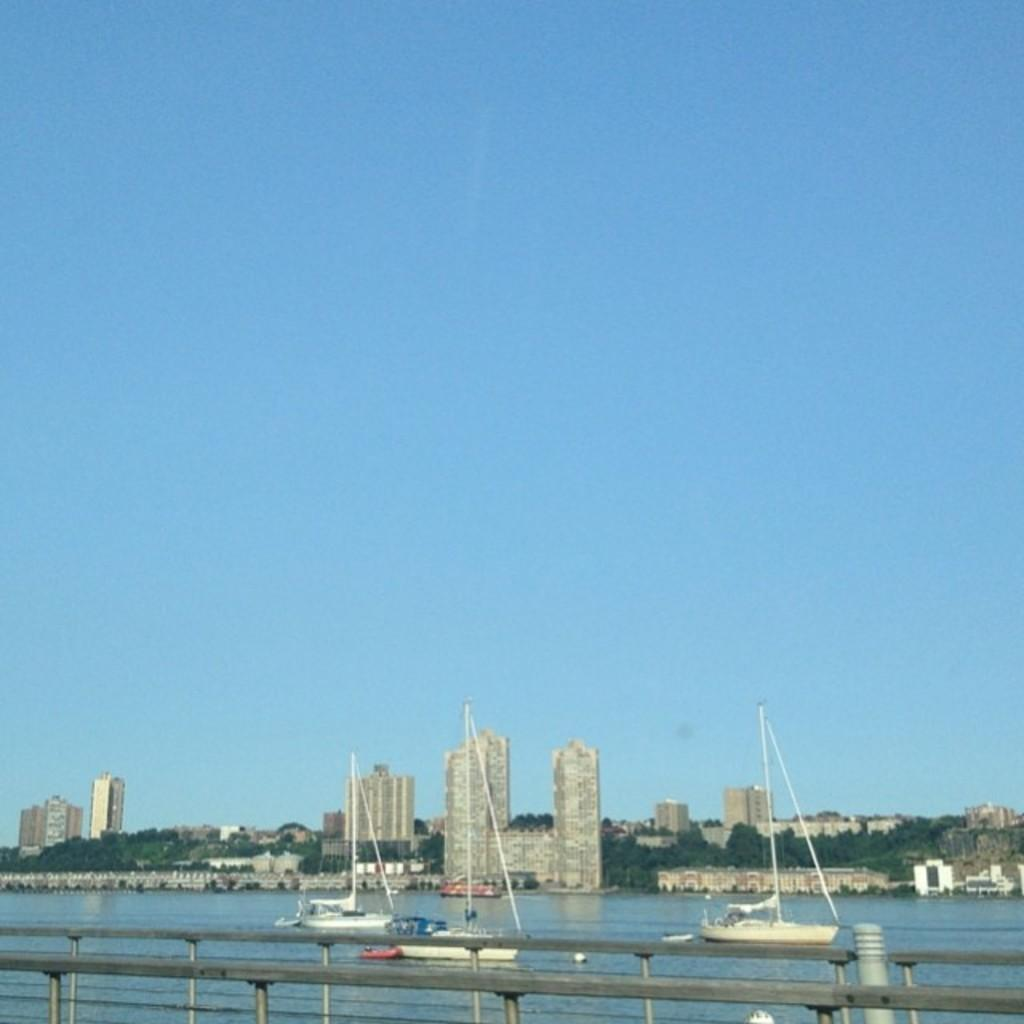What is on the water surface in the image? There are boats on the water surface in the image. What can be seen in the foreground area of the image? There is a boundary in the foreground area of the image. What is visible in the background of the image? There are buildings, trees, and the sky visible in the background of the image. How many clams can be seen on the boats in the image? There are no clams present in the image; it features boats on the water surface. What type of picture is hanging on the wall in the background of the image? There is no picture hanging on the wall in the background of the image; it features buildings, trees, and the sky. 